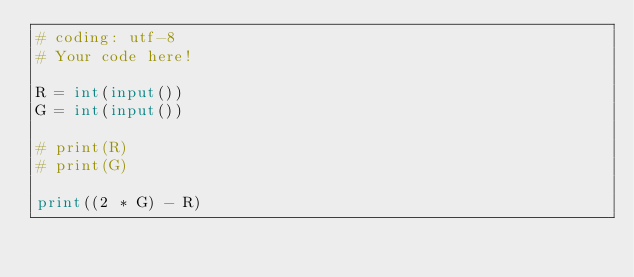Convert code to text. <code><loc_0><loc_0><loc_500><loc_500><_Python_># coding: utf-8
# Your code here!

R = int(input())
G = int(input())

# print(R)
# print(G)

print((2 * G) - R)</code> 